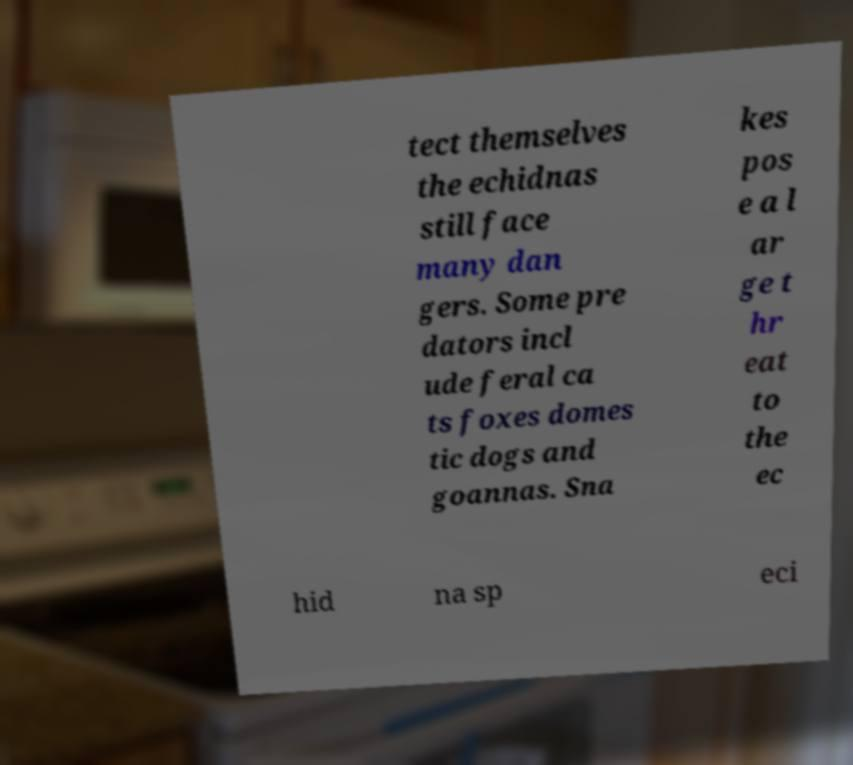Can you read and provide the text displayed in the image?This photo seems to have some interesting text. Can you extract and type it out for me? tect themselves the echidnas still face many dan gers. Some pre dators incl ude feral ca ts foxes domes tic dogs and goannas. Sna kes pos e a l ar ge t hr eat to the ec hid na sp eci 